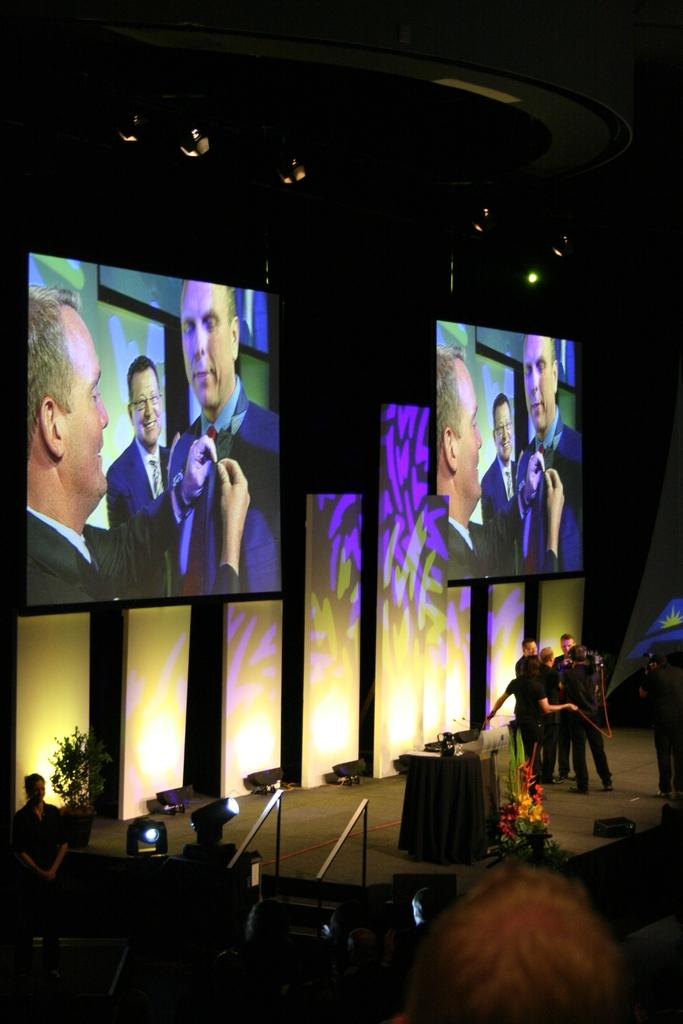What is the main feature of the image? There is a stage in the image. What is on the stage? There is a desk on the stage. Are there any people present on the stage? Yes, there are people standing beside the desk. What can be seen on the screens behind the people? There are two screens with images of the people behind them. What is the price of the tomatoes on the desk in the image? There are no tomatoes present on the desk in the image. What type of collar is visible on the people standing beside the desk? There is no collar visible on the people standing beside the desk in the image. 